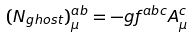<formula> <loc_0><loc_0><loc_500><loc_500>( N _ { g h o s t } ) ^ { a b } _ { \mu } = - g f ^ { a b c } A ^ { c } _ { \mu }</formula> 